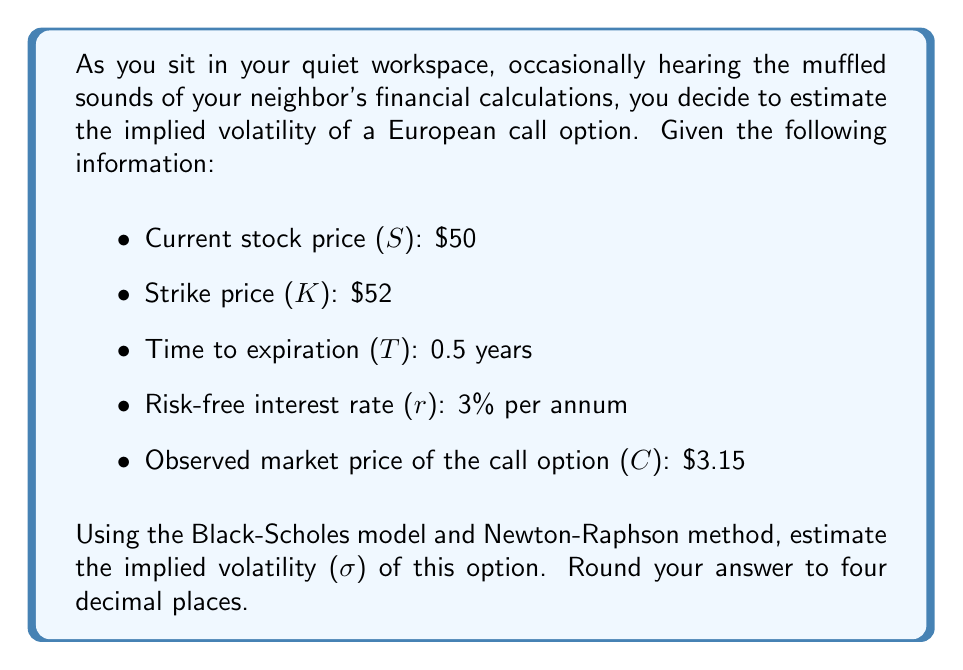Help me with this question. To estimate the implied volatility using the Black-Scholes model and Newton-Raphson method, we'll follow these steps:

1) The Black-Scholes formula for a European call option is:

   $$C = SN(d_1) - Ke^{-rT}N(d_2)$$

   Where:
   $$d_1 = \frac{\ln(S/K) + (r + \sigma^2/2)T}{\sigma\sqrt{T}}$$
   $$d_2 = d_1 - \sigma\sqrt{T}$$

2) We'll use the Newton-Raphson method to find σ:

   $$\sigma_{n+1} = \sigma_n - \frac{C(\sigma_n) - C_{market}}{vega(\sigma_n)}$$

   Where C(σ_n) is the Black-Scholes price using σ_n, and vega is the derivative of C with respect to σ.

3) The vega of a European call option is:

   $$vega = S\sqrt{T}N'(d_1)$$

   Where N'(x) is the standard normal probability density function.

4) We'll start with an initial guess of σ_0 = 0.3 and iterate until the difference between successive estimates is less than 0.0001.

5) Iteration 1:
   Calculate d_1, d_2, N(d_1), N(d_2), C(σ_0), and vega(σ_0)
   $$\sigma_1 = 0.3 - \frac{3.2721 - 3.15}{13.3945} = 0.2909$$

6) Iteration 2:
   Recalculate using σ_1 = 0.2909
   $$\sigma_2 = 0.2909 - \frac{3.1573 - 3.15}{13.0498} = 0.2905$$

7) Iteration 3:
   Recalculate using σ_2 = 0.2905
   $$\sigma_3 = 0.2905 - \frac{3.1501 - 3.15}{13.0314} = 0.2905$$

The process converges at σ ≈ 0.2905.
Answer: The estimated implied volatility is 0.2905 or 29.05%. 